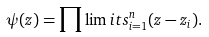Convert formula to latex. <formula><loc_0><loc_0><loc_500><loc_500>\psi ( z ) = \prod \lim i t s _ { i = 1 } ^ { n } ( z - z _ { i } ) .</formula> 